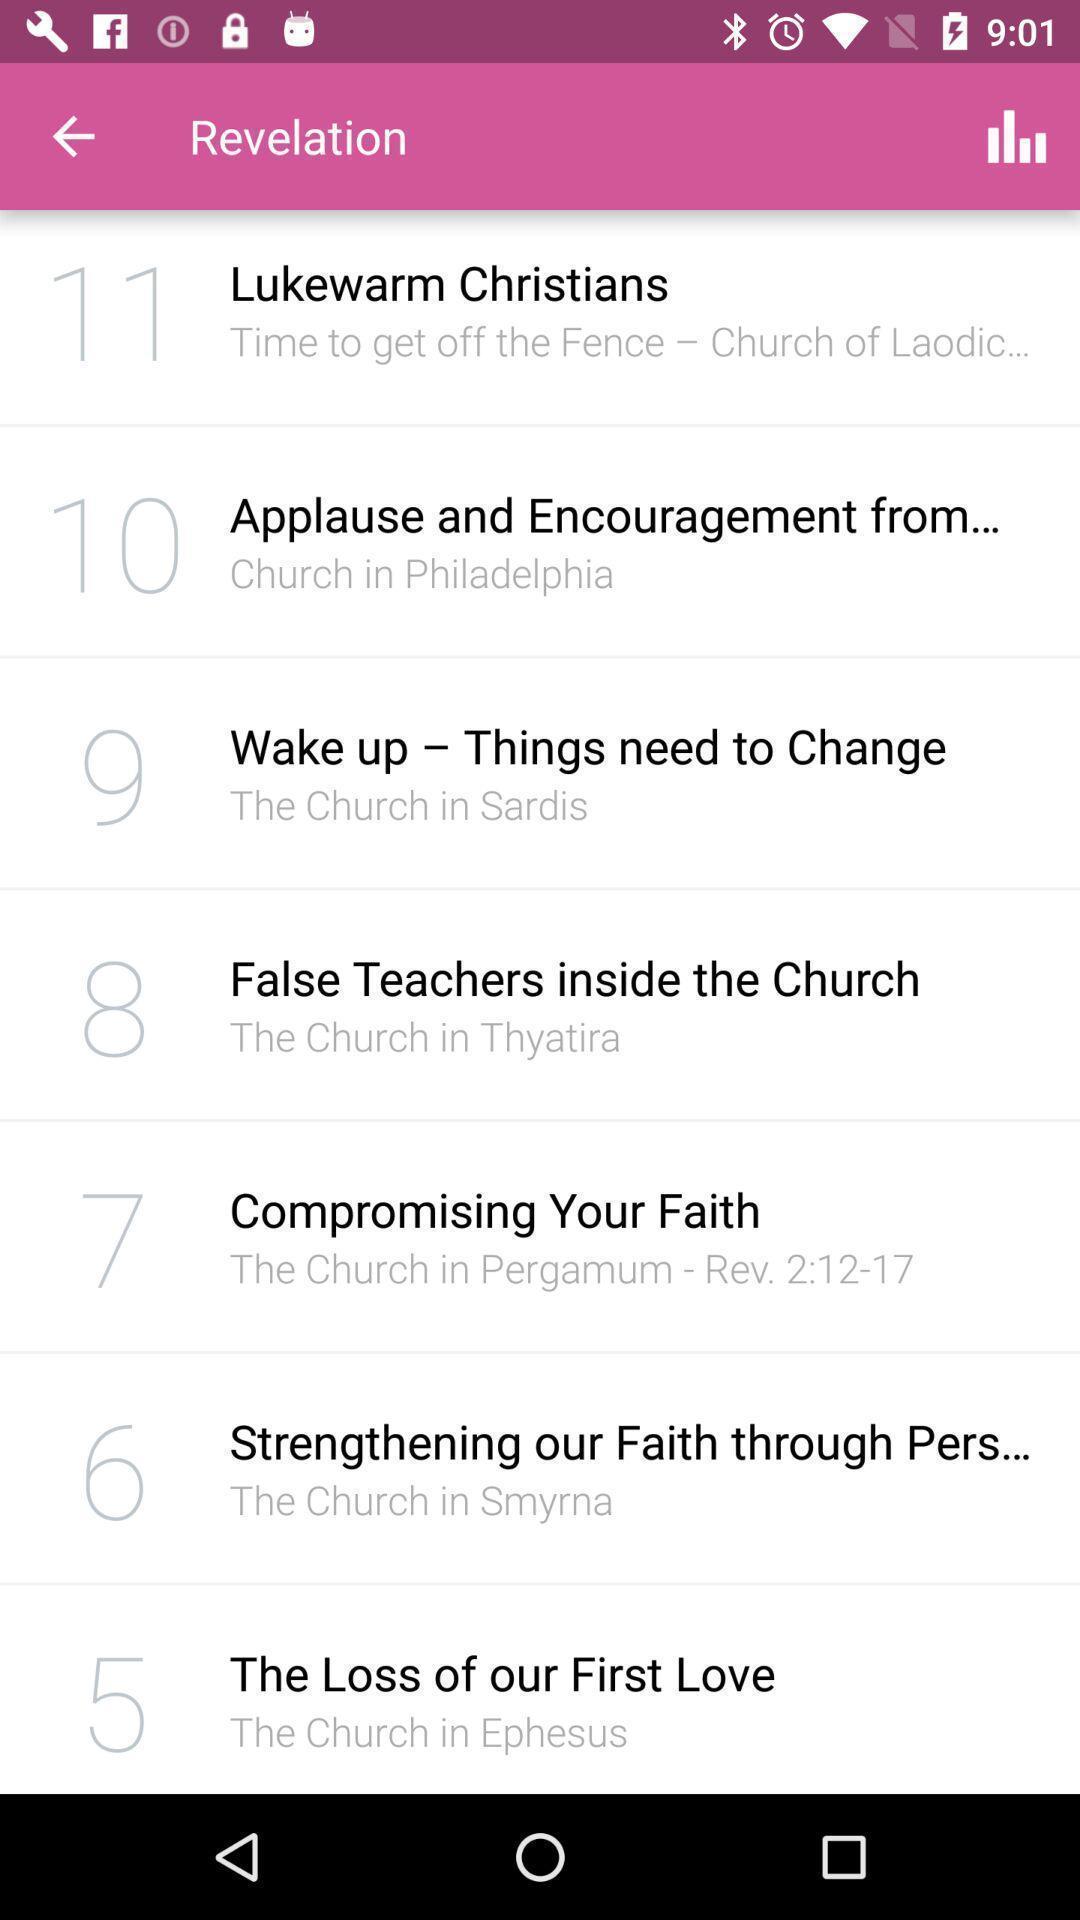Describe the visual elements of this screenshot. Revelation page shows options in an women 's health app. 